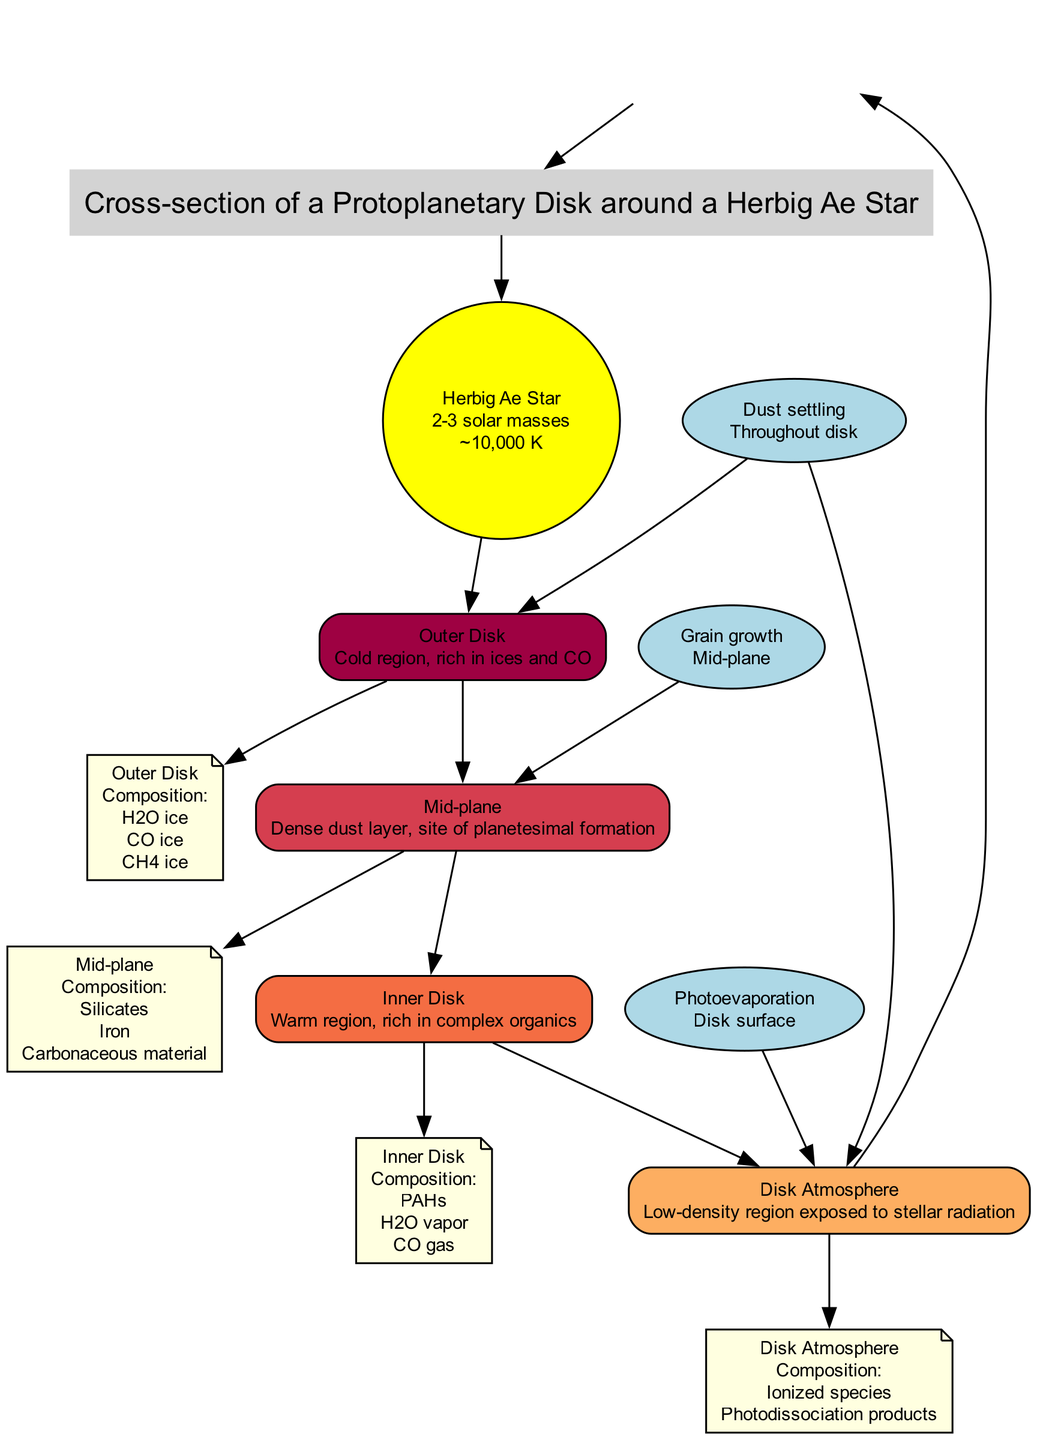What is the temperature of the Herbig Ae star? The diagram specifies the temperature of the Herbig Ae star as approximately 10,000 K, which is listed adjacent to the star node.
Answer: 10,000 K How many main components are shown in the protoplanetary disk? The diagram includes four main components in the protoplanetary disk: Outer Disk, Mid-plane, Inner Disk, and Disk Atmosphere. Counting these nodes gives us the total number of components.
Answer: 4 What compounds are listed in the Inner Disk? Referring to the Inner Disk node in the diagram, it specifies the compounds present there as PAHs, H2O vapor, and CO gas, which are detailed below the respective component label.
Answer: PAHs, H2O vapor, CO gas Which key process occurs in the Mid-plane? The ground indicates that the process of grain growth occurs specifically in the Mid-plane, establishing a direct connection between the process and its location.
Answer: Grain growth What does the Outer Disk region contain? The Outer Disk region contains H2O ice, CO ice, and CH4 ice, as listed in the corresponding chemical composition node attached to the Outer Disk component.
Answer: H2O ice, CO ice, CH4 ice What is the main chemical composition found in the Mid-plane? The Mid-plane chemical composition node indicates the presence of Silicates, Iron, and Carbonaceous material, providing explicit detail about what is found in this region.
Answer: Silicates, Iron, Carbonaceous material Where does photoevaporation occur? The diagram specifies that photoevaporation occurs at the Disk surface, connecting the process to its specific location within the disk structure as indicated in the diagram.
Answer: Disk surface Which region is rich in ices? The Outer Disk is characterized as a cold region that is rich in ices and CO, according to the description associated with this specific component in the diagram.
Answer: Outer Disk 